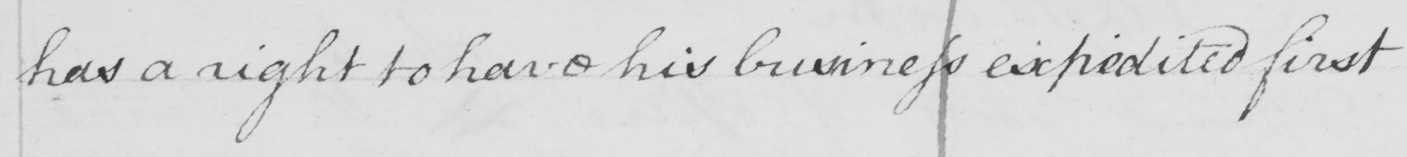Please provide the text content of this handwritten line. has a right to have his business expedited first 